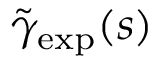<formula> <loc_0><loc_0><loc_500><loc_500>\tilde { \gamma } _ { e x p } ( s )</formula> 